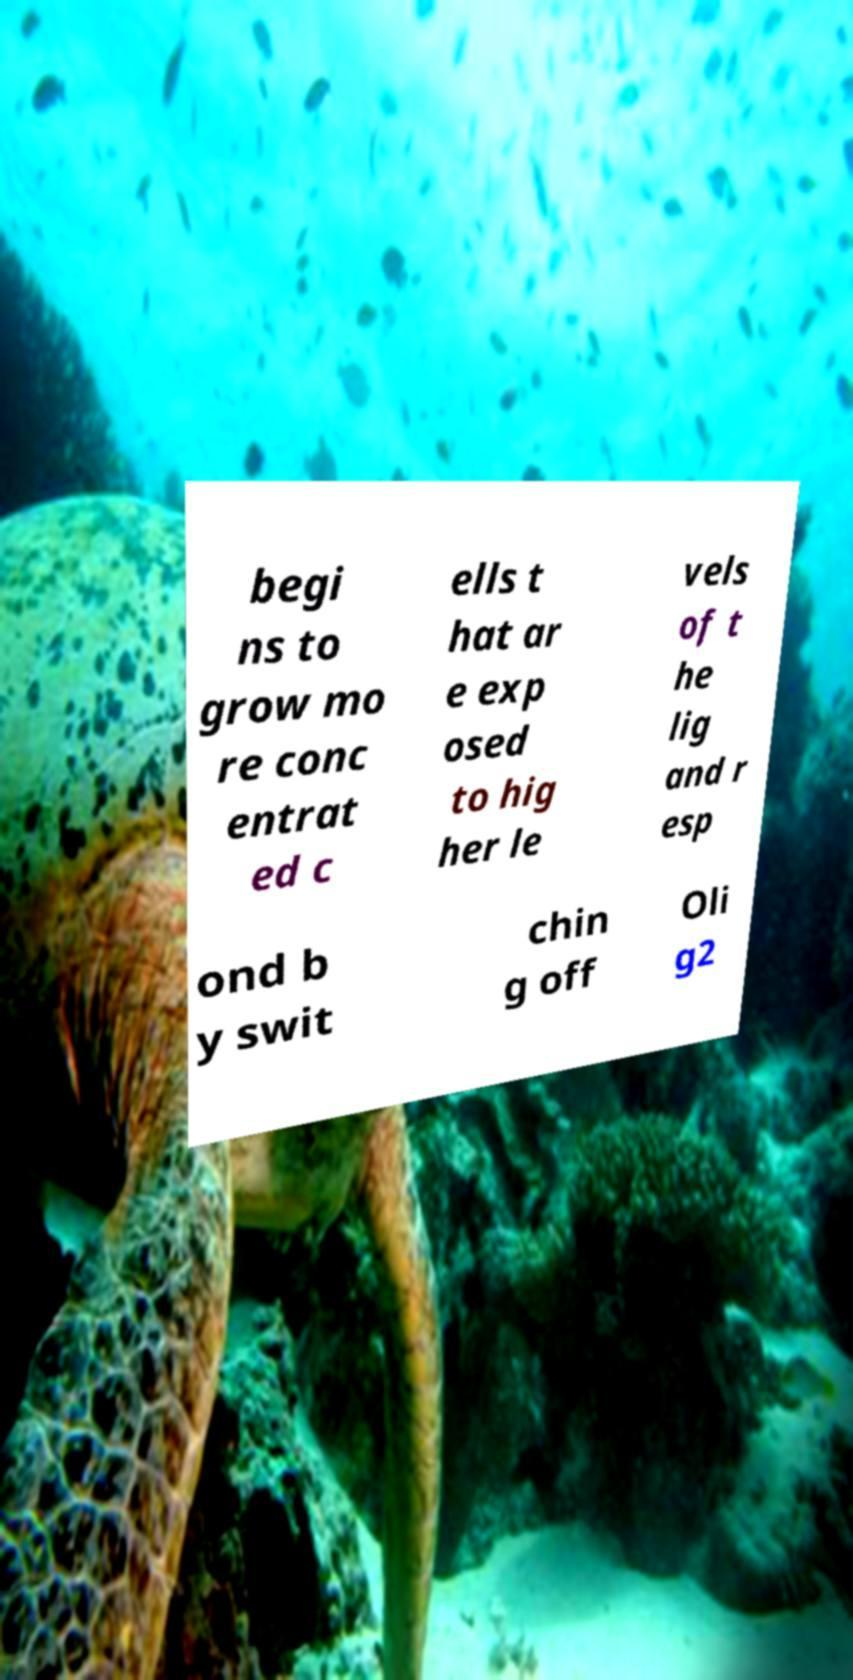For documentation purposes, I need the text within this image transcribed. Could you provide that? begi ns to grow mo re conc entrat ed c ells t hat ar e exp osed to hig her le vels of t he lig and r esp ond b y swit chin g off Oli g2 